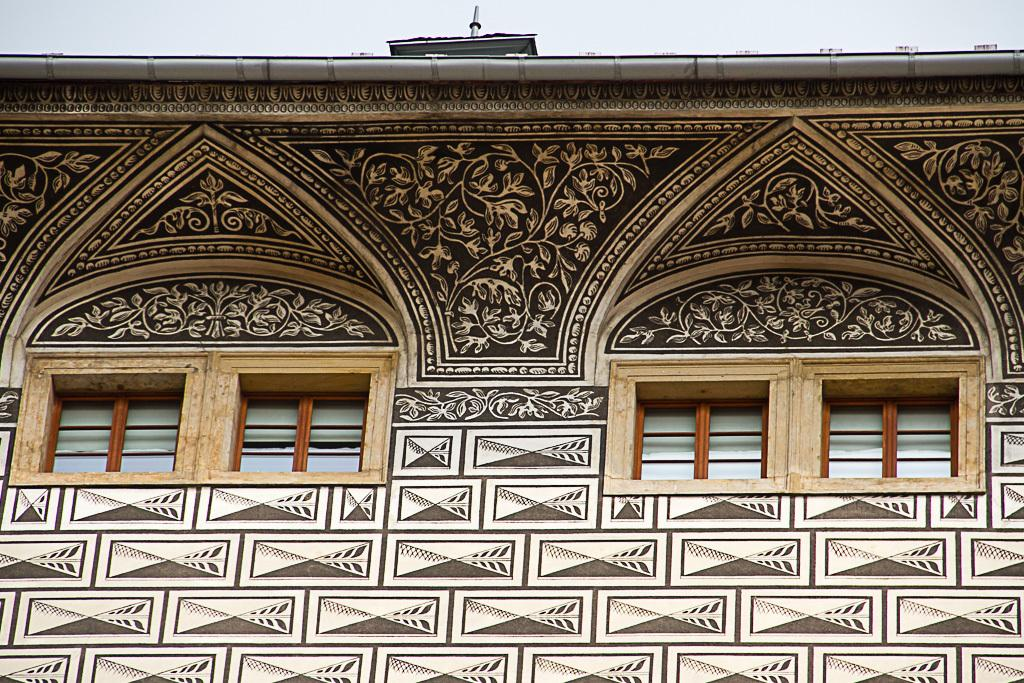What is visible in front of the image? There are windows and a building in front of the image. Can you describe the sky in the image? The sky is visible at the top of the image. Where is the nearest shop to purchase a bath towel in the image? There is no reference to a shop or a bath towel in the image, so it is not possible to answer that question. 